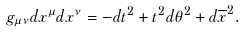<formula> <loc_0><loc_0><loc_500><loc_500>g _ { \mu \nu } d x ^ { \mu } d x ^ { \nu } = - d t ^ { 2 } + t ^ { 2 } d \theta ^ { 2 } + d \overline { x } ^ { 2 } .</formula> 